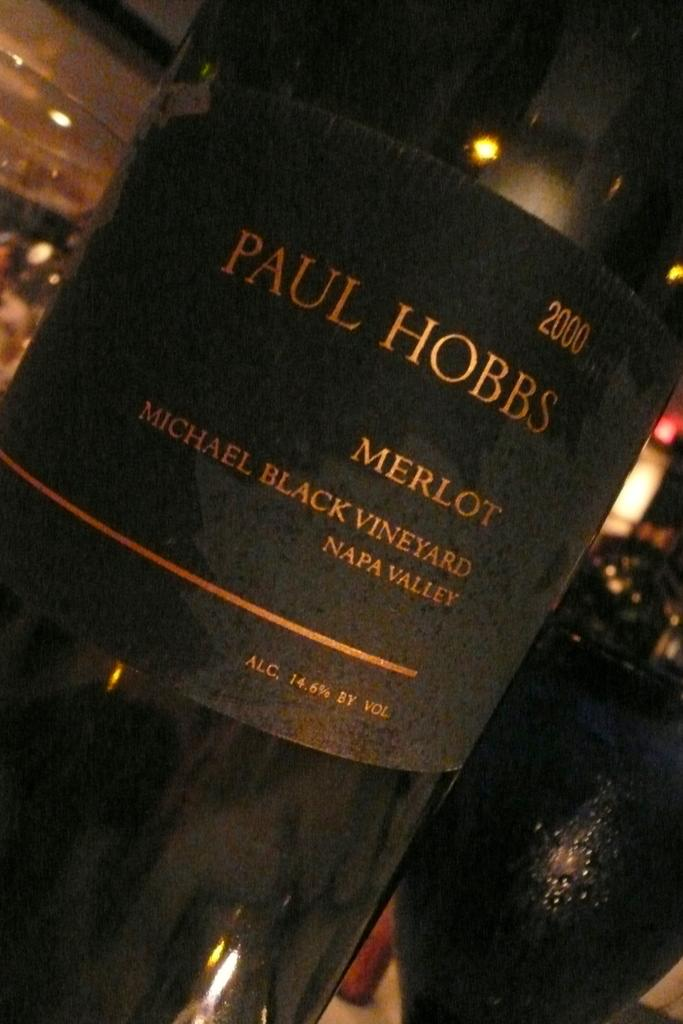What object is located in the center of the image? There is a beverage bottle in the center of the image. Can you describe the beverage bottle in more detail? Unfortunately, the provided facts do not offer any additional details about the beverage bottle. What type of canvas is being used to balance the beverage bottle in the image? There is no canvas or balancing act involving the beverage bottle in the image. 